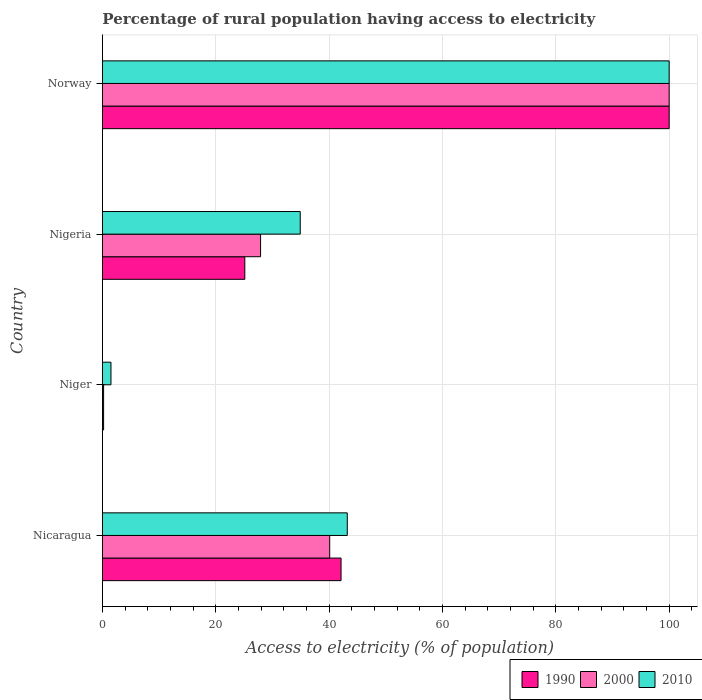Are the number of bars per tick equal to the number of legend labels?
Ensure brevity in your answer.  Yes. Are the number of bars on each tick of the Y-axis equal?
Ensure brevity in your answer.  Yes. What is the label of the 1st group of bars from the top?
Ensure brevity in your answer.  Norway. Across all countries, what is the maximum percentage of rural population having access to electricity in 1990?
Your response must be concise. 100. Across all countries, what is the minimum percentage of rural population having access to electricity in 2000?
Offer a very short reply. 0.2. In which country was the percentage of rural population having access to electricity in 2000 maximum?
Your answer should be compact. Norway. In which country was the percentage of rural population having access to electricity in 1990 minimum?
Ensure brevity in your answer.  Niger. What is the total percentage of rural population having access to electricity in 1990 in the graph?
Your response must be concise. 167.42. What is the difference between the percentage of rural population having access to electricity in 2010 in Nigeria and that in Norway?
Make the answer very short. -65.1. What is the average percentage of rural population having access to electricity in 2000 per country?
Provide a succinct answer. 42.05. In how many countries, is the percentage of rural population having access to electricity in 1990 greater than 12 %?
Your answer should be very brief. 3. What is the ratio of the percentage of rural population having access to electricity in 1990 in Niger to that in Nigeria?
Provide a short and direct response. 0.01. Is the difference between the percentage of rural population having access to electricity in 2010 in Nigeria and Norway greater than the difference between the percentage of rural population having access to electricity in 1990 in Nigeria and Norway?
Your response must be concise. Yes. What is the difference between the highest and the second highest percentage of rural population having access to electricity in 1990?
Your response must be concise. 57.9. What is the difference between the highest and the lowest percentage of rural population having access to electricity in 1990?
Offer a very short reply. 99.8. In how many countries, is the percentage of rural population having access to electricity in 2010 greater than the average percentage of rural population having access to electricity in 2010 taken over all countries?
Keep it short and to the point. 1. What does the 1st bar from the top in Nigeria represents?
Provide a succinct answer. 2010. Is it the case that in every country, the sum of the percentage of rural population having access to electricity in 1990 and percentage of rural population having access to electricity in 2000 is greater than the percentage of rural population having access to electricity in 2010?
Keep it short and to the point. No. How many bars are there?
Provide a short and direct response. 12. How many countries are there in the graph?
Provide a short and direct response. 4. Where does the legend appear in the graph?
Your answer should be very brief. Bottom right. How are the legend labels stacked?
Make the answer very short. Horizontal. What is the title of the graph?
Your answer should be very brief. Percentage of rural population having access to electricity. What is the label or title of the X-axis?
Your answer should be very brief. Access to electricity (% of population). What is the label or title of the Y-axis?
Provide a short and direct response. Country. What is the Access to electricity (% of population) in 1990 in Nicaragua?
Your answer should be very brief. 42.1. What is the Access to electricity (% of population) of 2000 in Nicaragua?
Your response must be concise. 40.1. What is the Access to electricity (% of population) in 2010 in Nicaragua?
Keep it short and to the point. 43.2. What is the Access to electricity (% of population) in 1990 in Niger?
Make the answer very short. 0.2. What is the Access to electricity (% of population) in 2000 in Niger?
Offer a terse response. 0.2. What is the Access to electricity (% of population) of 2010 in Niger?
Provide a succinct answer. 1.5. What is the Access to electricity (% of population) in 1990 in Nigeria?
Provide a succinct answer. 25.12. What is the Access to electricity (% of population) of 2000 in Nigeria?
Your response must be concise. 27.9. What is the Access to electricity (% of population) of 2010 in Nigeria?
Offer a terse response. 34.9. Across all countries, what is the maximum Access to electricity (% of population) of 1990?
Make the answer very short. 100. Across all countries, what is the maximum Access to electricity (% of population) in 2000?
Offer a very short reply. 100. Across all countries, what is the maximum Access to electricity (% of population) in 2010?
Offer a very short reply. 100. Across all countries, what is the minimum Access to electricity (% of population) in 2000?
Give a very brief answer. 0.2. Across all countries, what is the minimum Access to electricity (% of population) of 2010?
Ensure brevity in your answer.  1.5. What is the total Access to electricity (% of population) of 1990 in the graph?
Keep it short and to the point. 167.42. What is the total Access to electricity (% of population) in 2000 in the graph?
Keep it short and to the point. 168.2. What is the total Access to electricity (% of population) of 2010 in the graph?
Give a very brief answer. 179.6. What is the difference between the Access to electricity (% of population) of 1990 in Nicaragua and that in Niger?
Provide a short and direct response. 41.9. What is the difference between the Access to electricity (% of population) of 2000 in Nicaragua and that in Niger?
Make the answer very short. 39.9. What is the difference between the Access to electricity (% of population) in 2010 in Nicaragua and that in Niger?
Offer a terse response. 41.7. What is the difference between the Access to electricity (% of population) of 1990 in Nicaragua and that in Nigeria?
Provide a succinct answer. 16.98. What is the difference between the Access to electricity (% of population) in 2010 in Nicaragua and that in Nigeria?
Offer a terse response. 8.3. What is the difference between the Access to electricity (% of population) in 1990 in Nicaragua and that in Norway?
Offer a very short reply. -57.9. What is the difference between the Access to electricity (% of population) of 2000 in Nicaragua and that in Norway?
Ensure brevity in your answer.  -59.9. What is the difference between the Access to electricity (% of population) in 2010 in Nicaragua and that in Norway?
Offer a very short reply. -56.8. What is the difference between the Access to electricity (% of population) in 1990 in Niger and that in Nigeria?
Provide a short and direct response. -24.92. What is the difference between the Access to electricity (% of population) in 2000 in Niger and that in Nigeria?
Give a very brief answer. -27.7. What is the difference between the Access to electricity (% of population) in 2010 in Niger and that in Nigeria?
Your answer should be compact. -33.4. What is the difference between the Access to electricity (% of population) of 1990 in Niger and that in Norway?
Provide a succinct answer. -99.8. What is the difference between the Access to electricity (% of population) in 2000 in Niger and that in Norway?
Keep it short and to the point. -99.8. What is the difference between the Access to electricity (% of population) in 2010 in Niger and that in Norway?
Your answer should be compact. -98.5. What is the difference between the Access to electricity (% of population) in 1990 in Nigeria and that in Norway?
Provide a succinct answer. -74.88. What is the difference between the Access to electricity (% of population) of 2000 in Nigeria and that in Norway?
Your answer should be compact. -72.1. What is the difference between the Access to electricity (% of population) of 2010 in Nigeria and that in Norway?
Give a very brief answer. -65.1. What is the difference between the Access to electricity (% of population) in 1990 in Nicaragua and the Access to electricity (% of population) in 2000 in Niger?
Offer a very short reply. 41.9. What is the difference between the Access to electricity (% of population) in 1990 in Nicaragua and the Access to electricity (% of population) in 2010 in Niger?
Offer a terse response. 40.6. What is the difference between the Access to electricity (% of population) in 2000 in Nicaragua and the Access to electricity (% of population) in 2010 in Niger?
Offer a very short reply. 38.6. What is the difference between the Access to electricity (% of population) of 1990 in Nicaragua and the Access to electricity (% of population) of 2000 in Norway?
Offer a very short reply. -57.9. What is the difference between the Access to electricity (% of population) in 1990 in Nicaragua and the Access to electricity (% of population) in 2010 in Norway?
Offer a terse response. -57.9. What is the difference between the Access to electricity (% of population) in 2000 in Nicaragua and the Access to electricity (% of population) in 2010 in Norway?
Provide a succinct answer. -59.9. What is the difference between the Access to electricity (% of population) in 1990 in Niger and the Access to electricity (% of population) in 2000 in Nigeria?
Give a very brief answer. -27.7. What is the difference between the Access to electricity (% of population) in 1990 in Niger and the Access to electricity (% of population) in 2010 in Nigeria?
Provide a succinct answer. -34.7. What is the difference between the Access to electricity (% of population) of 2000 in Niger and the Access to electricity (% of population) of 2010 in Nigeria?
Keep it short and to the point. -34.7. What is the difference between the Access to electricity (% of population) of 1990 in Niger and the Access to electricity (% of population) of 2000 in Norway?
Give a very brief answer. -99.8. What is the difference between the Access to electricity (% of population) in 1990 in Niger and the Access to electricity (% of population) in 2010 in Norway?
Keep it short and to the point. -99.8. What is the difference between the Access to electricity (% of population) of 2000 in Niger and the Access to electricity (% of population) of 2010 in Norway?
Make the answer very short. -99.8. What is the difference between the Access to electricity (% of population) in 1990 in Nigeria and the Access to electricity (% of population) in 2000 in Norway?
Provide a short and direct response. -74.88. What is the difference between the Access to electricity (% of population) of 1990 in Nigeria and the Access to electricity (% of population) of 2010 in Norway?
Provide a short and direct response. -74.88. What is the difference between the Access to electricity (% of population) in 2000 in Nigeria and the Access to electricity (% of population) in 2010 in Norway?
Make the answer very short. -72.1. What is the average Access to electricity (% of population) in 1990 per country?
Your answer should be very brief. 41.85. What is the average Access to electricity (% of population) in 2000 per country?
Ensure brevity in your answer.  42.05. What is the average Access to electricity (% of population) in 2010 per country?
Provide a succinct answer. 44.9. What is the difference between the Access to electricity (% of population) in 1990 and Access to electricity (% of population) in 2000 in Nicaragua?
Ensure brevity in your answer.  2. What is the difference between the Access to electricity (% of population) of 1990 and Access to electricity (% of population) of 2010 in Nicaragua?
Provide a short and direct response. -1.1. What is the difference between the Access to electricity (% of population) of 1990 and Access to electricity (% of population) of 2000 in Nigeria?
Your answer should be compact. -2.78. What is the difference between the Access to electricity (% of population) in 1990 and Access to electricity (% of population) in 2010 in Nigeria?
Your response must be concise. -9.78. What is the difference between the Access to electricity (% of population) of 1990 and Access to electricity (% of population) of 2010 in Norway?
Your response must be concise. 0. What is the difference between the Access to electricity (% of population) of 2000 and Access to electricity (% of population) of 2010 in Norway?
Provide a short and direct response. 0. What is the ratio of the Access to electricity (% of population) in 1990 in Nicaragua to that in Niger?
Keep it short and to the point. 210.5. What is the ratio of the Access to electricity (% of population) of 2000 in Nicaragua to that in Niger?
Your answer should be very brief. 200.5. What is the ratio of the Access to electricity (% of population) in 2010 in Nicaragua to that in Niger?
Provide a succinct answer. 28.8. What is the ratio of the Access to electricity (% of population) in 1990 in Nicaragua to that in Nigeria?
Provide a short and direct response. 1.68. What is the ratio of the Access to electricity (% of population) in 2000 in Nicaragua to that in Nigeria?
Offer a terse response. 1.44. What is the ratio of the Access to electricity (% of population) of 2010 in Nicaragua to that in Nigeria?
Keep it short and to the point. 1.24. What is the ratio of the Access to electricity (% of population) in 1990 in Nicaragua to that in Norway?
Provide a succinct answer. 0.42. What is the ratio of the Access to electricity (% of population) in 2000 in Nicaragua to that in Norway?
Ensure brevity in your answer.  0.4. What is the ratio of the Access to electricity (% of population) in 2010 in Nicaragua to that in Norway?
Provide a succinct answer. 0.43. What is the ratio of the Access to electricity (% of population) in 1990 in Niger to that in Nigeria?
Offer a terse response. 0.01. What is the ratio of the Access to electricity (% of population) in 2000 in Niger to that in Nigeria?
Offer a very short reply. 0.01. What is the ratio of the Access to electricity (% of population) in 2010 in Niger to that in Nigeria?
Provide a succinct answer. 0.04. What is the ratio of the Access to electricity (% of population) in 1990 in Niger to that in Norway?
Keep it short and to the point. 0. What is the ratio of the Access to electricity (% of population) of 2000 in Niger to that in Norway?
Your response must be concise. 0. What is the ratio of the Access to electricity (% of population) in 2010 in Niger to that in Norway?
Ensure brevity in your answer.  0.01. What is the ratio of the Access to electricity (% of population) in 1990 in Nigeria to that in Norway?
Your answer should be compact. 0.25. What is the ratio of the Access to electricity (% of population) in 2000 in Nigeria to that in Norway?
Provide a succinct answer. 0.28. What is the ratio of the Access to electricity (% of population) of 2010 in Nigeria to that in Norway?
Make the answer very short. 0.35. What is the difference between the highest and the second highest Access to electricity (% of population) of 1990?
Make the answer very short. 57.9. What is the difference between the highest and the second highest Access to electricity (% of population) in 2000?
Provide a succinct answer. 59.9. What is the difference between the highest and the second highest Access to electricity (% of population) of 2010?
Your response must be concise. 56.8. What is the difference between the highest and the lowest Access to electricity (% of population) in 1990?
Your answer should be very brief. 99.8. What is the difference between the highest and the lowest Access to electricity (% of population) of 2000?
Your answer should be compact. 99.8. What is the difference between the highest and the lowest Access to electricity (% of population) of 2010?
Offer a very short reply. 98.5. 